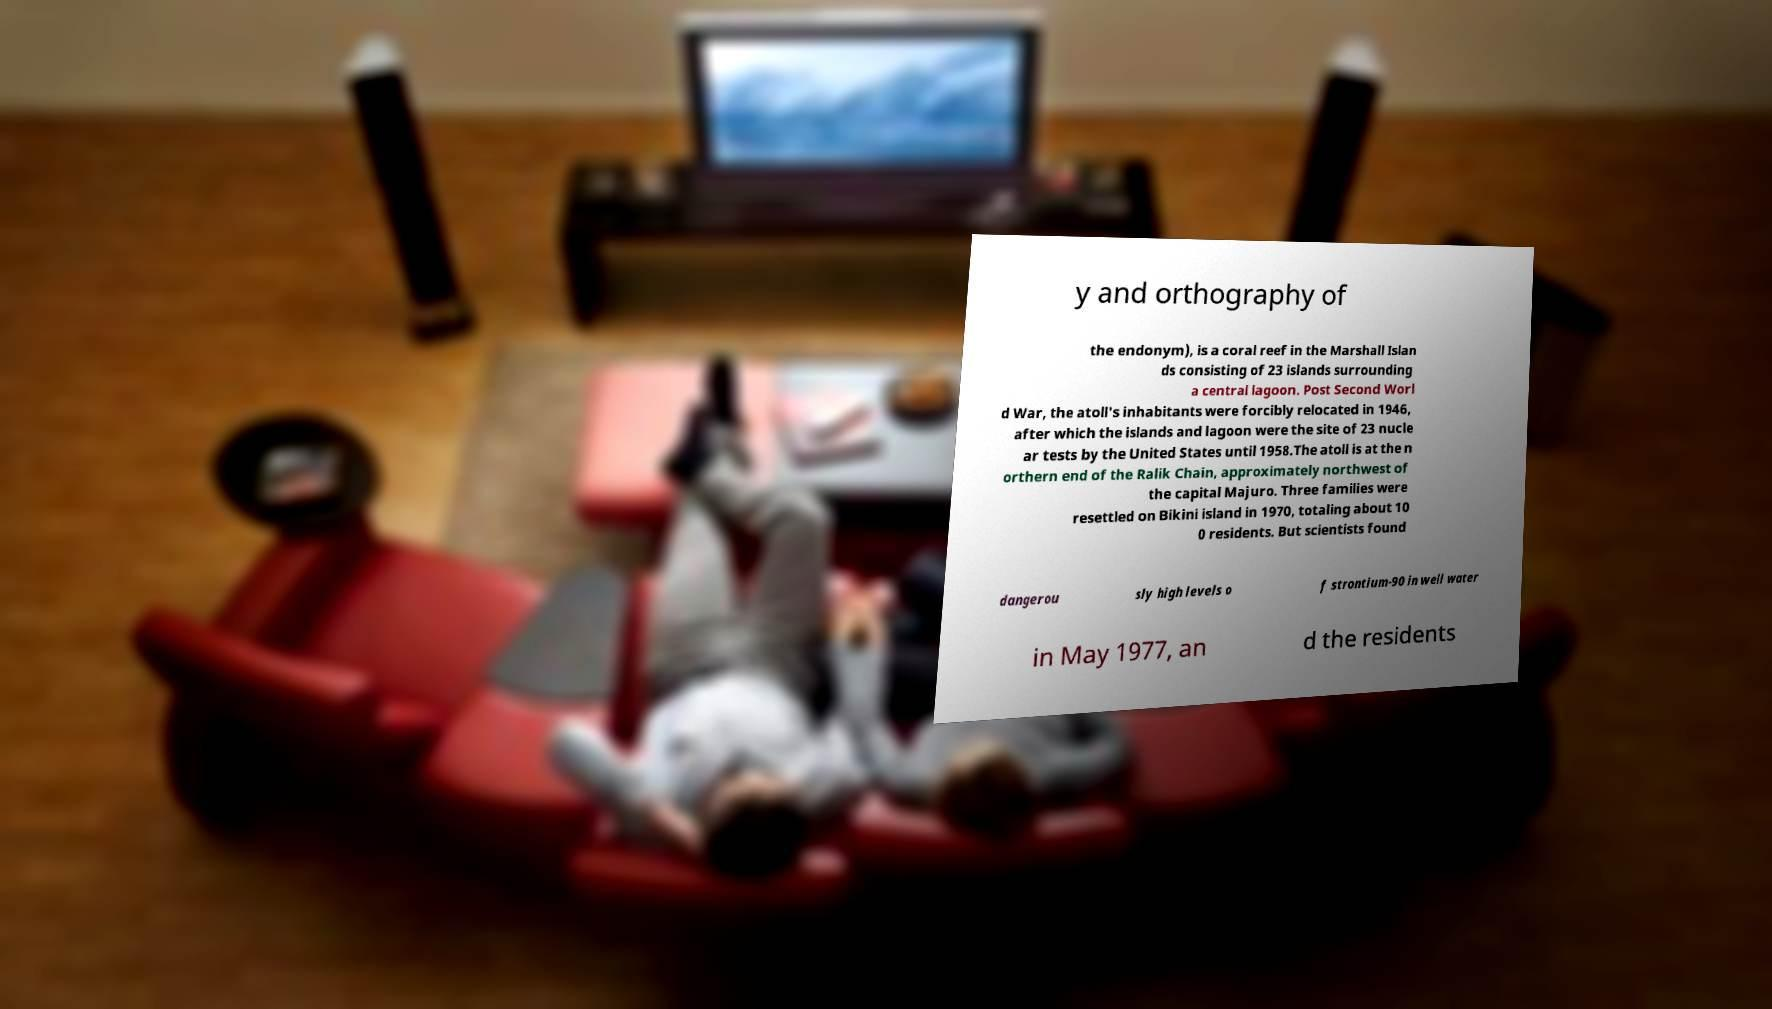Please identify and transcribe the text found in this image. y and orthography of the endonym), is a coral reef in the Marshall Islan ds consisting of 23 islands surrounding a central lagoon. Post Second Worl d War, the atoll's inhabitants were forcibly relocated in 1946, after which the islands and lagoon were the site of 23 nucle ar tests by the United States until 1958.The atoll is at the n orthern end of the Ralik Chain, approximately northwest of the capital Majuro. Three families were resettled on Bikini island in 1970, totaling about 10 0 residents. But scientists found dangerou sly high levels o f strontium-90 in well water in May 1977, an d the residents 